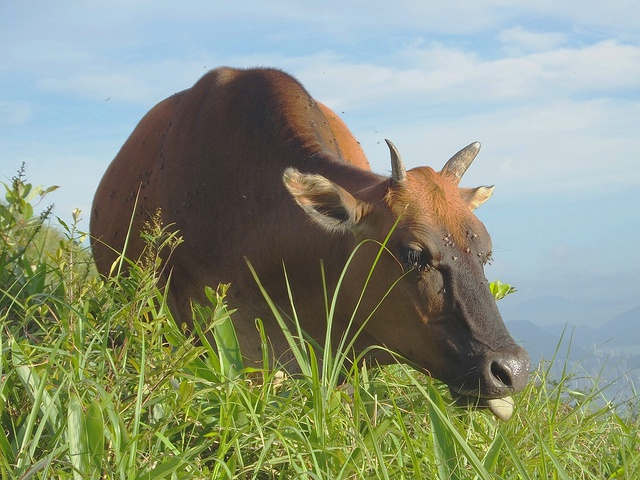Describe the objects in this image and their specific colors. I can see a cow in lightblue, black, and gray tones in this image. 